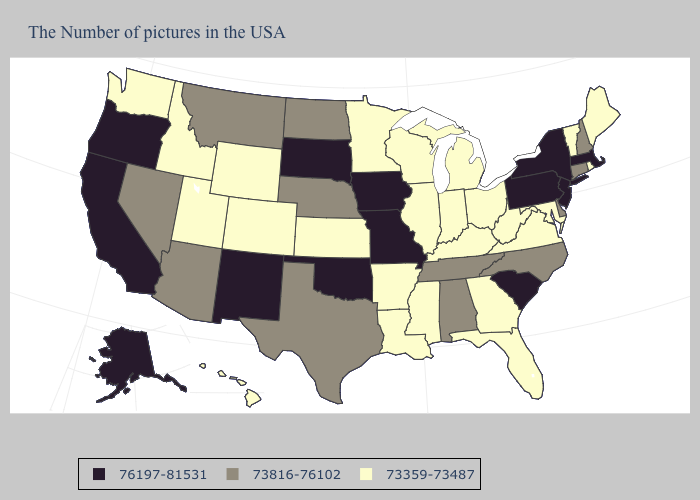Does Montana have the highest value in the West?
Concise answer only. No. What is the value of Montana?
Concise answer only. 73816-76102. Does New Jersey have the lowest value in the Northeast?
Write a very short answer. No. Name the states that have a value in the range 73359-73487?
Keep it brief. Maine, Rhode Island, Vermont, Maryland, Virginia, West Virginia, Ohio, Florida, Georgia, Michigan, Kentucky, Indiana, Wisconsin, Illinois, Mississippi, Louisiana, Arkansas, Minnesota, Kansas, Wyoming, Colorado, Utah, Idaho, Washington, Hawaii. Which states have the lowest value in the South?
Write a very short answer. Maryland, Virginia, West Virginia, Florida, Georgia, Kentucky, Mississippi, Louisiana, Arkansas. Does the map have missing data?
Concise answer only. No. What is the value of Virginia?
Give a very brief answer. 73359-73487. Name the states that have a value in the range 73816-76102?
Concise answer only. New Hampshire, Connecticut, Delaware, North Carolina, Alabama, Tennessee, Nebraska, Texas, North Dakota, Montana, Arizona, Nevada. What is the lowest value in the MidWest?
Concise answer only. 73359-73487. Does Iowa have the highest value in the USA?
Short answer required. Yes. What is the value of Massachusetts?
Quick response, please. 76197-81531. Is the legend a continuous bar?
Quick response, please. No. What is the highest value in states that border Arizona?
Short answer required. 76197-81531. Among the states that border Ohio , does Pennsylvania have the highest value?
Give a very brief answer. Yes. 